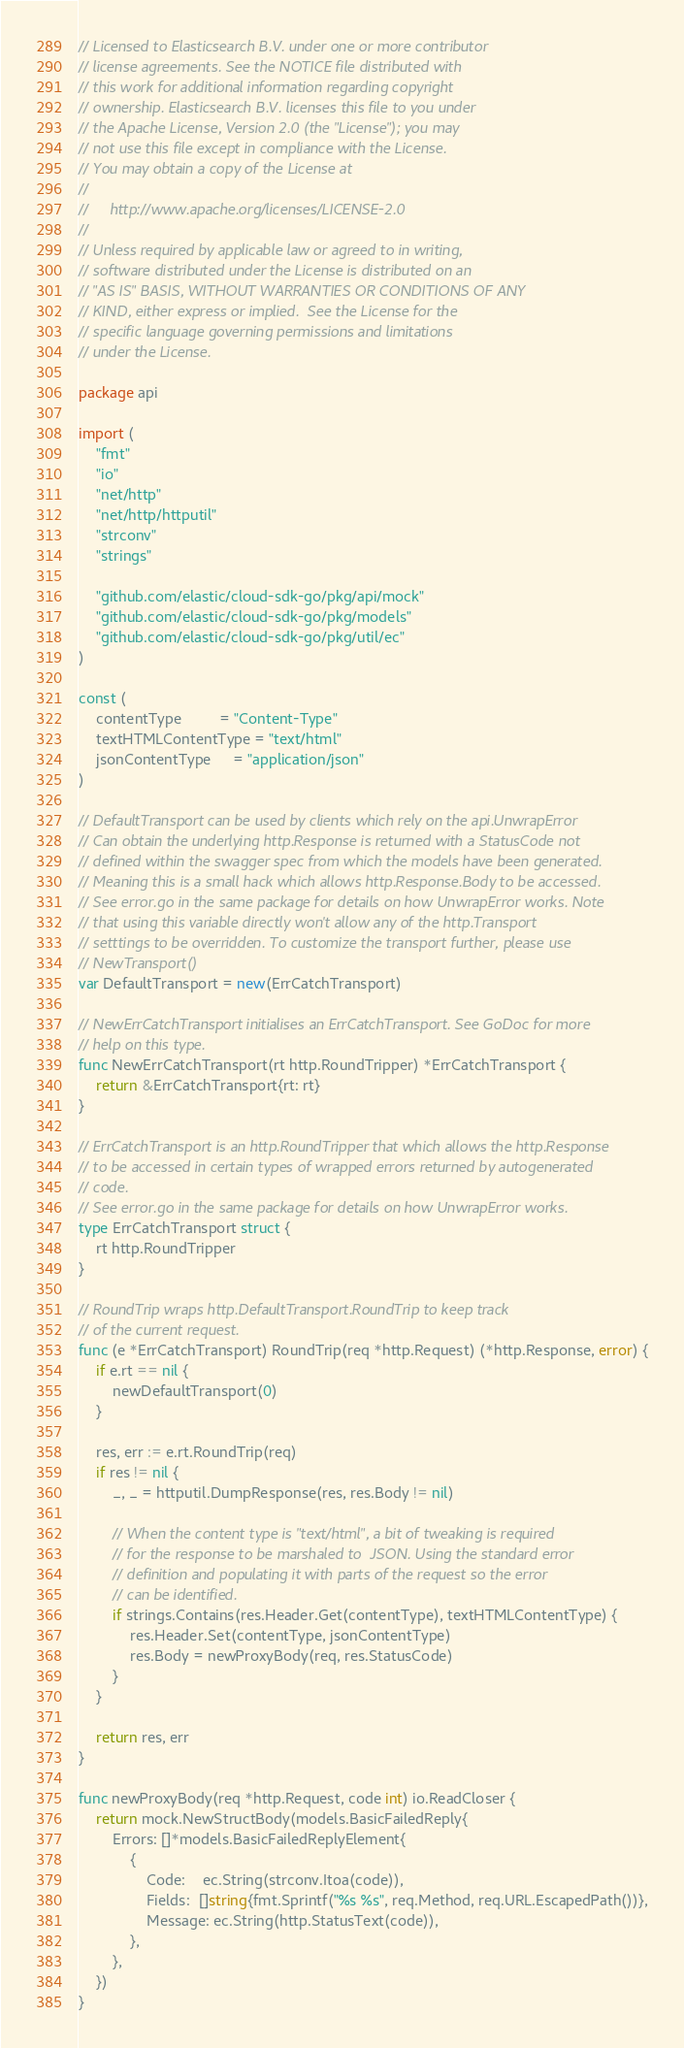<code> <loc_0><loc_0><loc_500><loc_500><_Go_>// Licensed to Elasticsearch B.V. under one or more contributor
// license agreements. See the NOTICE file distributed with
// this work for additional information regarding copyright
// ownership. Elasticsearch B.V. licenses this file to you under
// the Apache License, Version 2.0 (the "License"); you may
// not use this file except in compliance with the License.
// You may obtain a copy of the License at
//
//     http://www.apache.org/licenses/LICENSE-2.0
//
// Unless required by applicable law or agreed to in writing,
// software distributed under the License is distributed on an
// "AS IS" BASIS, WITHOUT WARRANTIES OR CONDITIONS OF ANY
// KIND, either express or implied.  See the License for the
// specific language governing permissions and limitations
// under the License.

package api

import (
	"fmt"
	"io"
	"net/http"
	"net/http/httputil"
	"strconv"
	"strings"

	"github.com/elastic/cloud-sdk-go/pkg/api/mock"
	"github.com/elastic/cloud-sdk-go/pkg/models"
	"github.com/elastic/cloud-sdk-go/pkg/util/ec"
)

const (
	contentType         = "Content-Type"
	textHTMLContentType = "text/html"
	jsonContentType     = "application/json"
)

// DefaultTransport can be used by clients which rely on the api.UnwrapError
// Can obtain the underlying http.Response is returned with a StatusCode not
// defined within the swagger spec from which the models have been generated.
// Meaning this is a small hack which allows http.Response.Body to be accessed.
// See error.go in the same package for details on how UnwrapError works. Note
// that using this variable directly won't allow any of the http.Transport
// setttings to be overridden. To customize the transport further, please use
// NewTransport()
var DefaultTransport = new(ErrCatchTransport)

// NewErrCatchTransport initialises an ErrCatchTransport. See GoDoc for more
// help on this type.
func NewErrCatchTransport(rt http.RoundTripper) *ErrCatchTransport {
	return &ErrCatchTransport{rt: rt}
}

// ErrCatchTransport is an http.RoundTripper that which allows the http.Response
// to be accessed in certain types of wrapped errors returned by autogenerated
// code.
// See error.go in the same package for details on how UnwrapError works.
type ErrCatchTransport struct {
	rt http.RoundTripper
}

// RoundTrip wraps http.DefaultTransport.RoundTrip to keep track
// of the current request.
func (e *ErrCatchTransport) RoundTrip(req *http.Request) (*http.Response, error) {
	if e.rt == nil {
		newDefaultTransport(0)
	}

	res, err := e.rt.RoundTrip(req)
	if res != nil {
		_, _ = httputil.DumpResponse(res, res.Body != nil)

		// When the content type is "text/html", a bit of tweaking is required
		// for the response to be marshaled to  JSON. Using the standard error
		// definition and populating it with parts of the request so the error
		// can be identified.
		if strings.Contains(res.Header.Get(contentType), textHTMLContentType) {
			res.Header.Set(contentType, jsonContentType)
			res.Body = newProxyBody(req, res.StatusCode)
		}
	}

	return res, err
}

func newProxyBody(req *http.Request, code int) io.ReadCloser {
	return mock.NewStructBody(models.BasicFailedReply{
		Errors: []*models.BasicFailedReplyElement{
			{
				Code:    ec.String(strconv.Itoa(code)),
				Fields:  []string{fmt.Sprintf("%s %s", req.Method, req.URL.EscapedPath())},
				Message: ec.String(http.StatusText(code)),
			},
		},
	})
}
</code> 